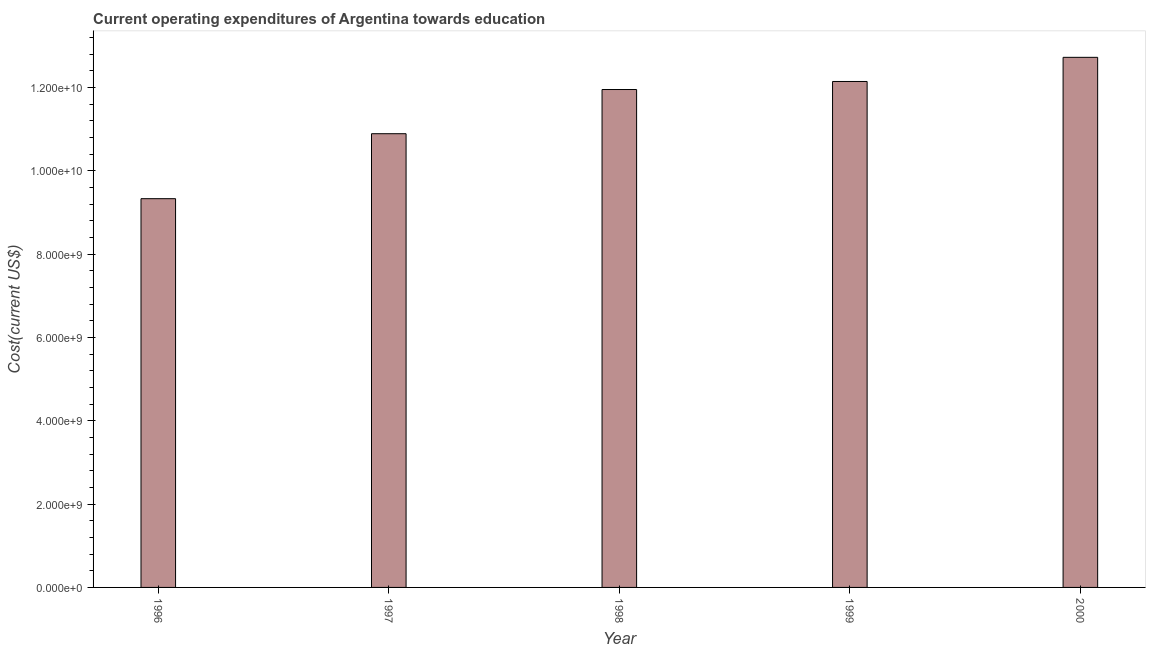What is the title of the graph?
Keep it short and to the point. Current operating expenditures of Argentina towards education. What is the label or title of the Y-axis?
Your answer should be very brief. Cost(current US$). What is the education expenditure in 2000?
Make the answer very short. 1.27e+1. Across all years, what is the maximum education expenditure?
Your answer should be compact. 1.27e+1. Across all years, what is the minimum education expenditure?
Ensure brevity in your answer.  9.33e+09. In which year was the education expenditure maximum?
Make the answer very short. 2000. In which year was the education expenditure minimum?
Provide a short and direct response. 1996. What is the sum of the education expenditure?
Your answer should be compact. 5.71e+1. What is the difference between the education expenditure in 1997 and 1998?
Your answer should be very brief. -1.06e+09. What is the average education expenditure per year?
Keep it short and to the point. 1.14e+1. What is the median education expenditure?
Keep it short and to the point. 1.20e+1. Do a majority of the years between 2000 and 1996 (inclusive) have education expenditure greater than 11600000000 US$?
Offer a terse response. Yes. What is the ratio of the education expenditure in 1996 to that in 2000?
Offer a very short reply. 0.73. Is the difference between the education expenditure in 1996 and 1999 greater than the difference between any two years?
Provide a short and direct response. No. What is the difference between the highest and the second highest education expenditure?
Provide a short and direct response. 5.80e+08. Is the sum of the education expenditure in 1998 and 2000 greater than the maximum education expenditure across all years?
Give a very brief answer. Yes. What is the difference between the highest and the lowest education expenditure?
Your answer should be very brief. 3.39e+09. How many bars are there?
Your answer should be very brief. 5. Are all the bars in the graph horizontal?
Offer a very short reply. No. How many years are there in the graph?
Keep it short and to the point. 5. What is the Cost(current US$) of 1996?
Offer a terse response. 9.33e+09. What is the Cost(current US$) in 1997?
Your answer should be compact. 1.09e+1. What is the Cost(current US$) in 1998?
Provide a short and direct response. 1.20e+1. What is the Cost(current US$) in 1999?
Your answer should be compact. 1.21e+1. What is the Cost(current US$) in 2000?
Give a very brief answer. 1.27e+1. What is the difference between the Cost(current US$) in 1996 and 1997?
Make the answer very short. -1.56e+09. What is the difference between the Cost(current US$) in 1996 and 1998?
Your response must be concise. -2.62e+09. What is the difference between the Cost(current US$) in 1996 and 1999?
Provide a short and direct response. -2.81e+09. What is the difference between the Cost(current US$) in 1996 and 2000?
Keep it short and to the point. -3.39e+09. What is the difference between the Cost(current US$) in 1997 and 1998?
Ensure brevity in your answer.  -1.06e+09. What is the difference between the Cost(current US$) in 1997 and 1999?
Your answer should be very brief. -1.25e+09. What is the difference between the Cost(current US$) in 1997 and 2000?
Offer a very short reply. -1.83e+09. What is the difference between the Cost(current US$) in 1998 and 1999?
Your answer should be compact. -1.93e+08. What is the difference between the Cost(current US$) in 1998 and 2000?
Make the answer very short. -7.73e+08. What is the difference between the Cost(current US$) in 1999 and 2000?
Your answer should be very brief. -5.80e+08. What is the ratio of the Cost(current US$) in 1996 to that in 1997?
Provide a succinct answer. 0.86. What is the ratio of the Cost(current US$) in 1996 to that in 1998?
Your answer should be very brief. 0.78. What is the ratio of the Cost(current US$) in 1996 to that in 1999?
Offer a terse response. 0.77. What is the ratio of the Cost(current US$) in 1996 to that in 2000?
Give a very brief answer. 0.73. What is the ratio of the Cost(current US$) in 1997 to that in 1998?
Offer a terse response. 0.91. What is the ratio of the Cost(current US$) in 1997 to that in 1999?
Offer a terse response. 0.9. What is the ratio of the Cost(current US$) in 1997 to that in 2000?
Your answer should be compact. 0.86. What is the ratio of the Cost(current US$) in 1998 to that in 1999?
Offer a very short reply. 0.98. What is the ratio of the Cost(current US$) in 1998 to that in 2000?
Give a very brief answer. 0.94. What is the ratio of the Cost(current US$) in 1999 to that in 2000?
Offer a terse response. 0.95. 